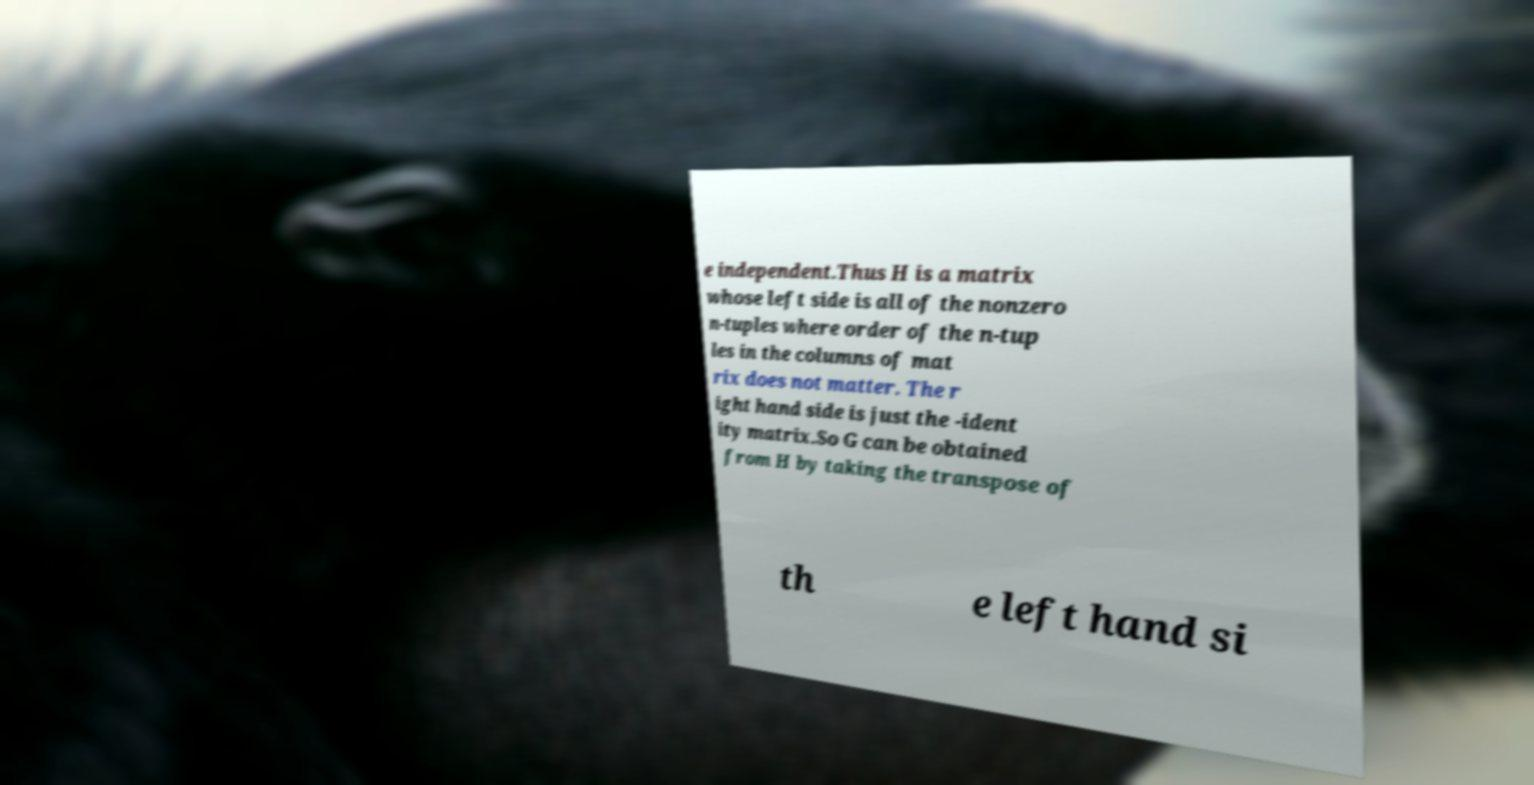I need the written content from this picture converted into text. Can you do that? e independent.Thus H is a matrix whose left side is all of the nonzero n-tuples where order of the n-tup les in the columns of mat rix does not matter. The r ight hand side is just the -ident ity matrix.So G can be obtained from H by taking the transpose of th e left hand si 